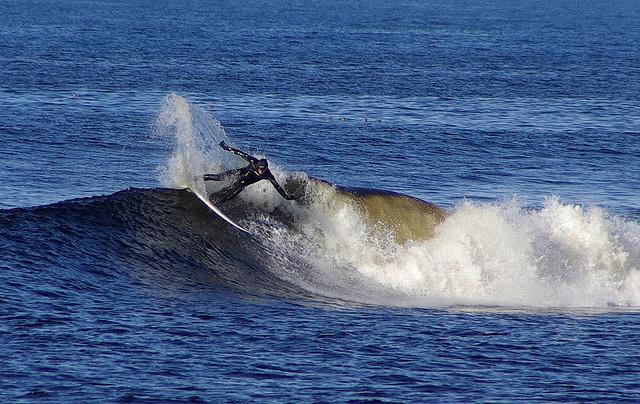How many people are in the water?
Answer briefly. 1. What color is the surfer's board?
Short answer required. White. What color is the wave?
Give a very brief answer. Blue. 